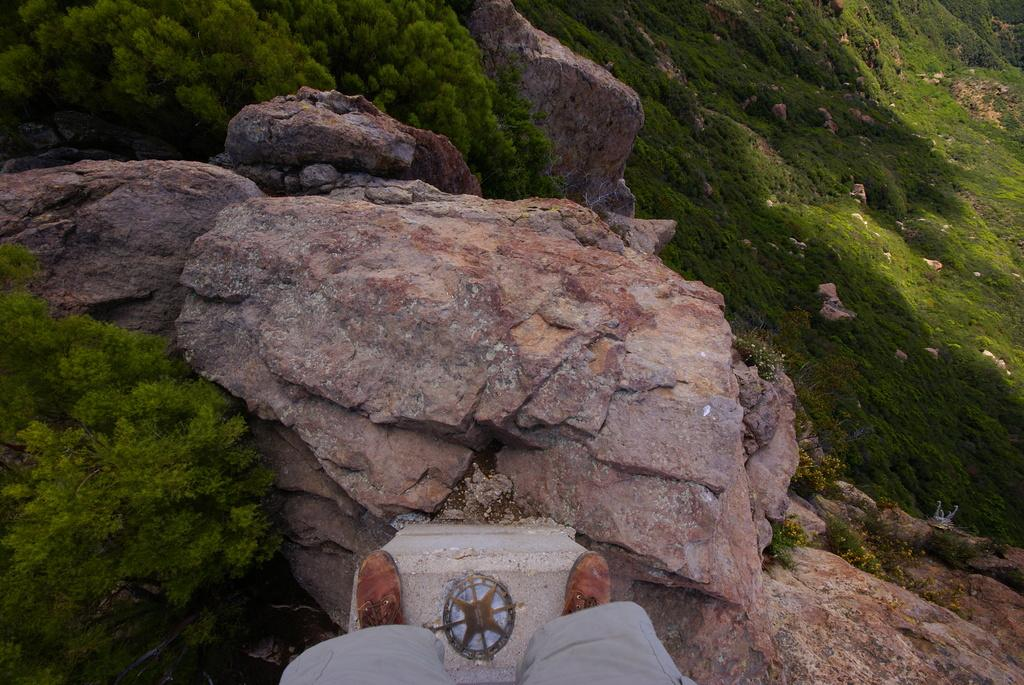What can be seen in the image related to a person? There is a person in the image. What clothing can be seen on the person's legs? The person's legs are wearing grey-colored shorts. What type of footwear is the person wearing? The person is wearing brown-colored shoes. What is the surface the person is standing on? The person is standing on a rock surface. What type of natural elements are present in the image? There are trees, rocks, and grass in the image. What type of bun is the person holding in the image? There is no bun present in the image. How many planes can be seen flying in the image? There are no planes visible in the image. 